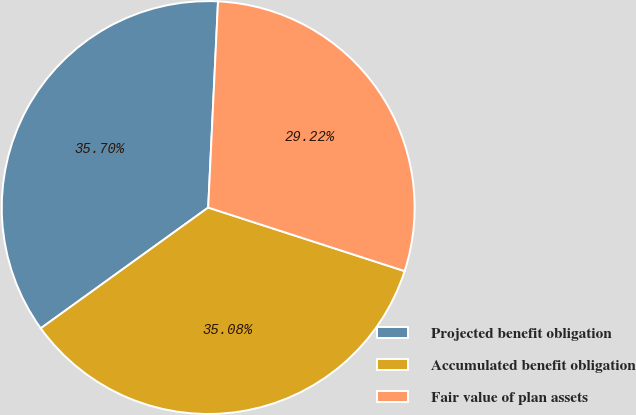<chart> <loc_0><loc_0><loc_500><loc_500><pie_chart><fcel>Projected benefit obligation<fcel>Accumulated benefit obligation<fcel>Fair value of plan assets<nl><fcel>35.7%<fcel>35.08%<fcel>29.22%<nl></chart> 